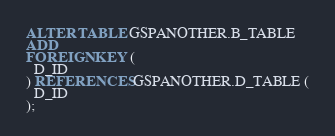<code> <loc_0><loc_0><loc_500><loc_500><_SQL_>ALTER TABLE GSPANOTHER.B_TABLE
ADD 
FOREIGN KEY (
  D_ID
) REFERENCES GSPANOTHER.D_TABLE (
  D_ID
);
</code> 